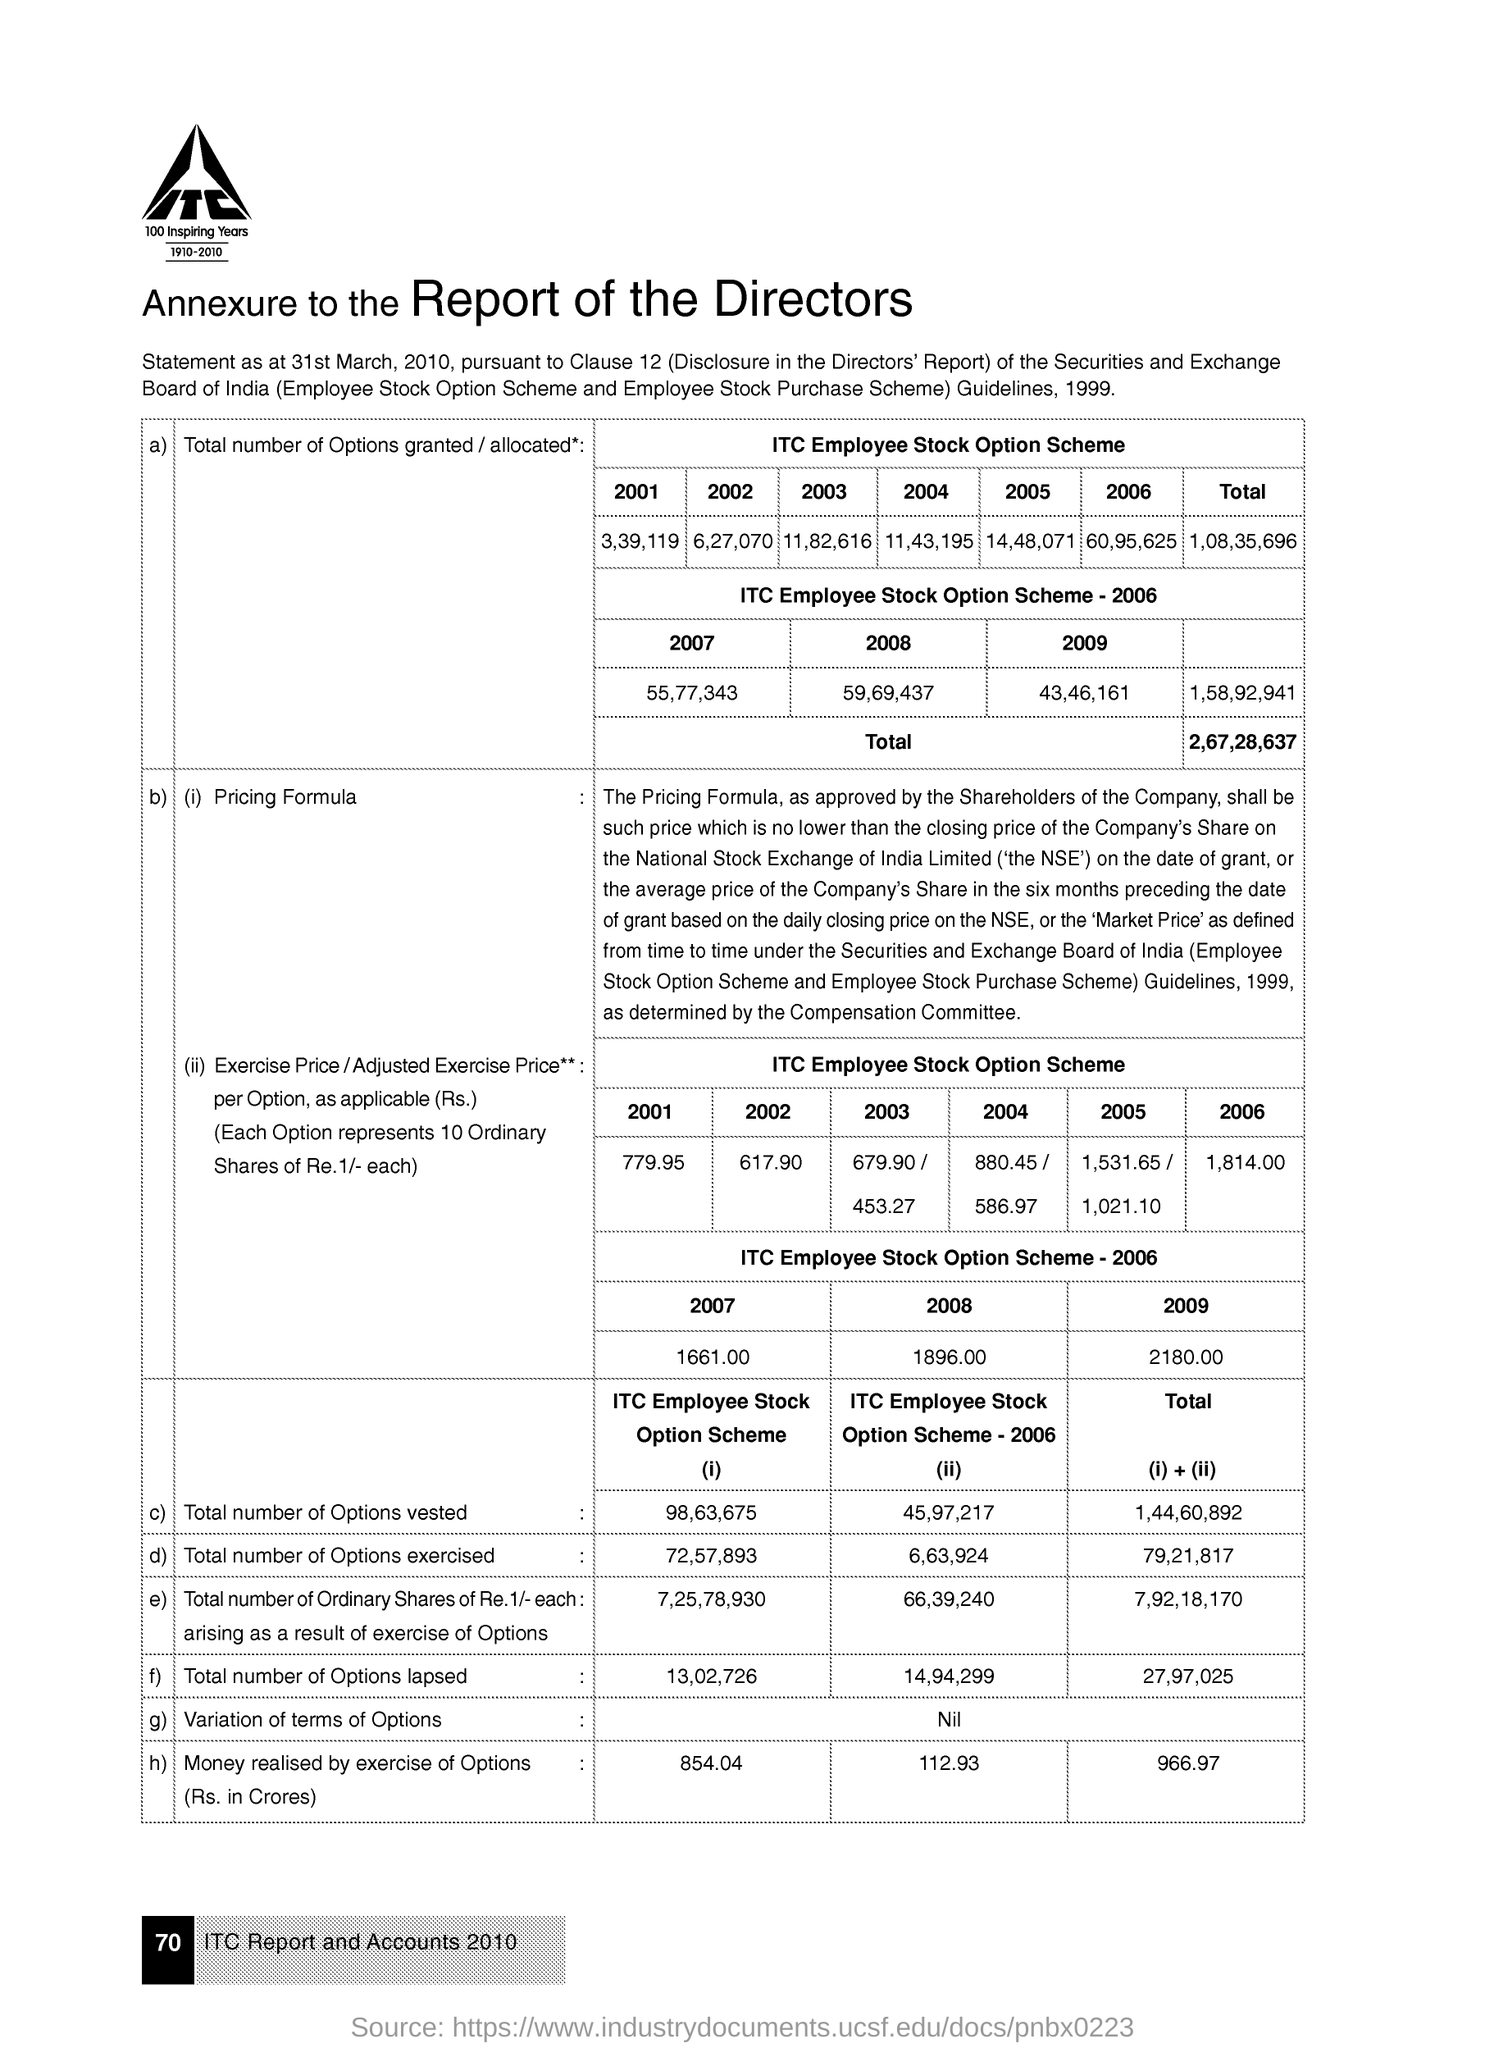What is the total number of options granted under itc employee stock option scheme in the year 2002 ?
Your response must be concise. 6,27,070. What is the total number of options granted under the itc employee stock option scheme in the year 2004 ?
Ensure brevity in your answer.  11,43,195. What is the total number of options granted under itc employee stock option scheme in the year 2001 ?
Give a very brief answer. 3,39,119. What is the value of total number of options vested under itc employee stock option scheme ?
Offer a very short reply. 98,63,675. What is the exercise price per option under the itc employee stock option scheme in the year 2001 ?
Your answer should be compact. 779.95. What is the exercise price per option under the itc employee stock option scheme in the year 2006?
Your response must be concise. 1,814.00. What is the total number of options lapsed under the itc employee stock option scheme -2006 ?
Ensure brevity in your answer.  14,94,299. What is the value of total number of options exercised under the itc employees stock option scheme -2006 ?
Provide a succinct answer. 6,63,924. What is the value of total number of options granted under the itc employee stock option scheme in the year 2009 ?
Your answer should be very brief. 43,46,161. 